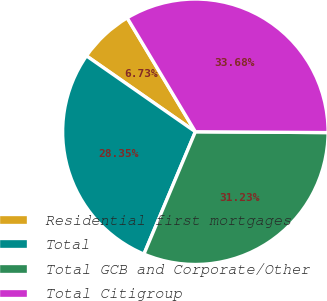Convert chart to OTSL. <chart><loc_0><loc_0><loc_500><loc_500><pie_chart><fcel>Residential first mortgages<fcel>Total<fcel>Total GCB and Corporate/Other<fcel>Total Citigroup<nl><fcel>6.73%<fcel>28.35%<fcel>31.23%<fcel>33.68%<nl></chart> 